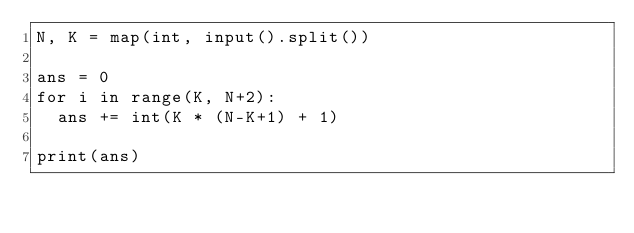Convert code to text. <code><loc_0><loc_0><loc_500><loc_500><_Python_>N, K = map(int, input().split())

ans = 0
for i in range(K, N+2):
  ans += int(K * (N-K+1) + 1)
  
print(ans)</code> 